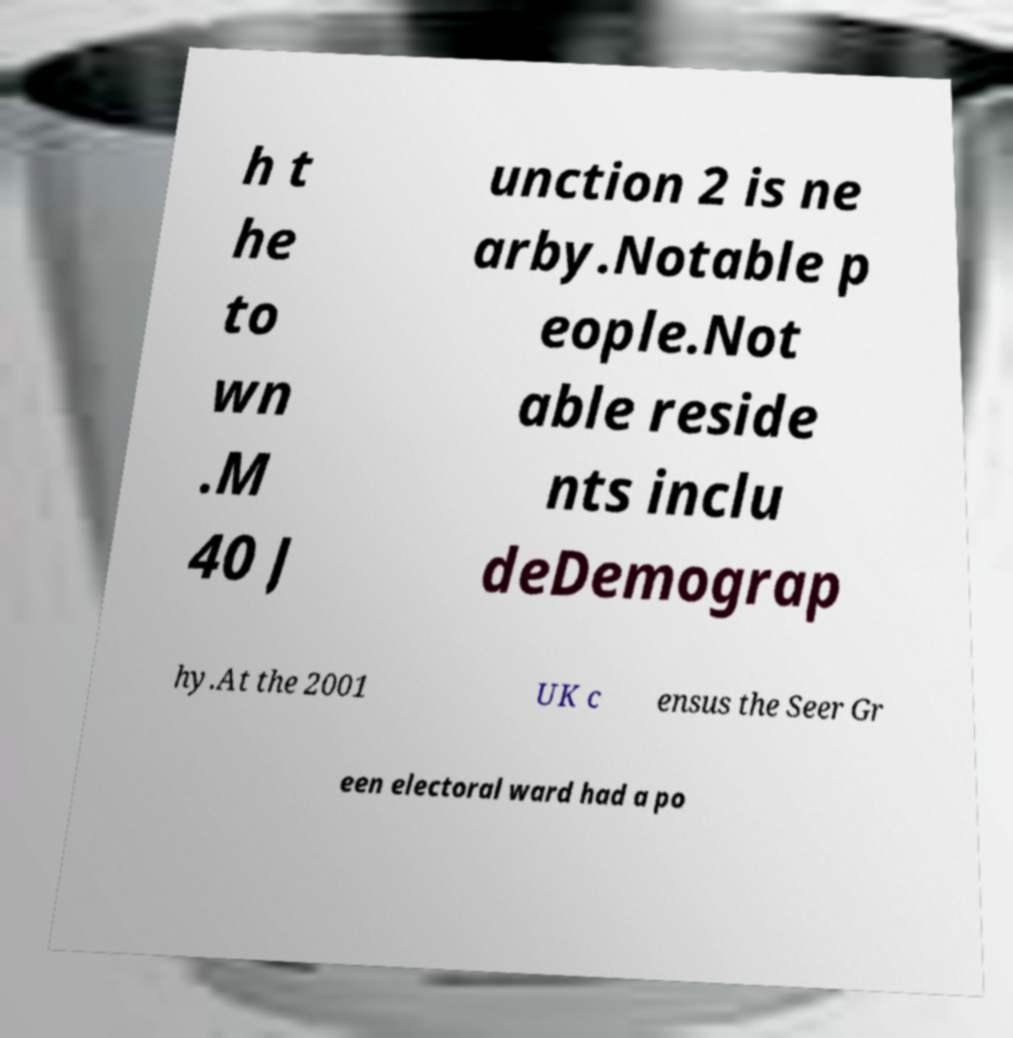Can you read and provide the text displayed in the image?This photo seems to have some interesting text. Can you extract and type it out for me? h t he to wn .M 40 J unction 2 is ne arby.Notable p eople.Not able reside nts inclu deDemograp hy.At the 2001 UK c ensus the Seer Gr een electoral ward had a po 